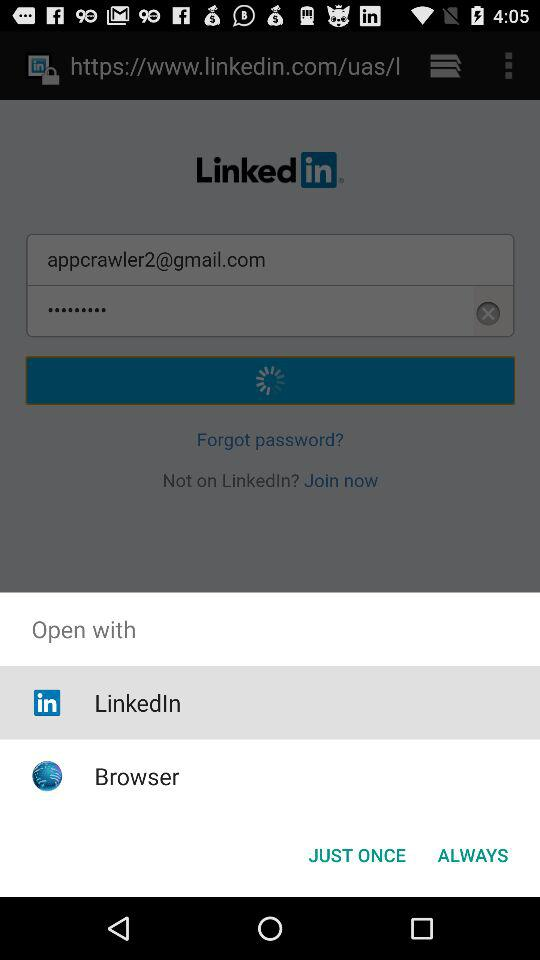Which application can I use to open the web site? You can use the "LinkedIn" and "Browser" applications to open the web site. 